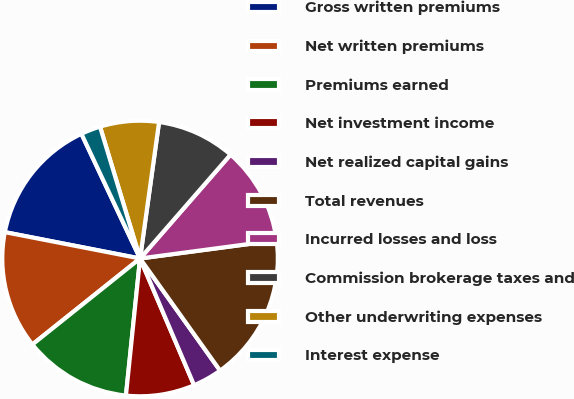Convert chart. <chart><loc_0><loc_0><loc_500><loc_500><pie_chart><fcel>Gross written premiums<fcel>Net written premiums<fcel>Premiums earned<fcel>Net investment income<fcel>Net realized capital gains<fcel>Total revenues<fcel>Incurred losses and loss<fcel>Commission brokerage taxes and<fcel>Other underwriting expenses<fcel>Interest expense<nl><fcel>14.94%<fcel>13.79%<fcel>12.64%<fcel>8.05%<fcel>3.45%<fcel>17.24%<fcel>11.49%<fcel>9.2%<fcel>6.9%<fcel>2.3%<nl></chart> 